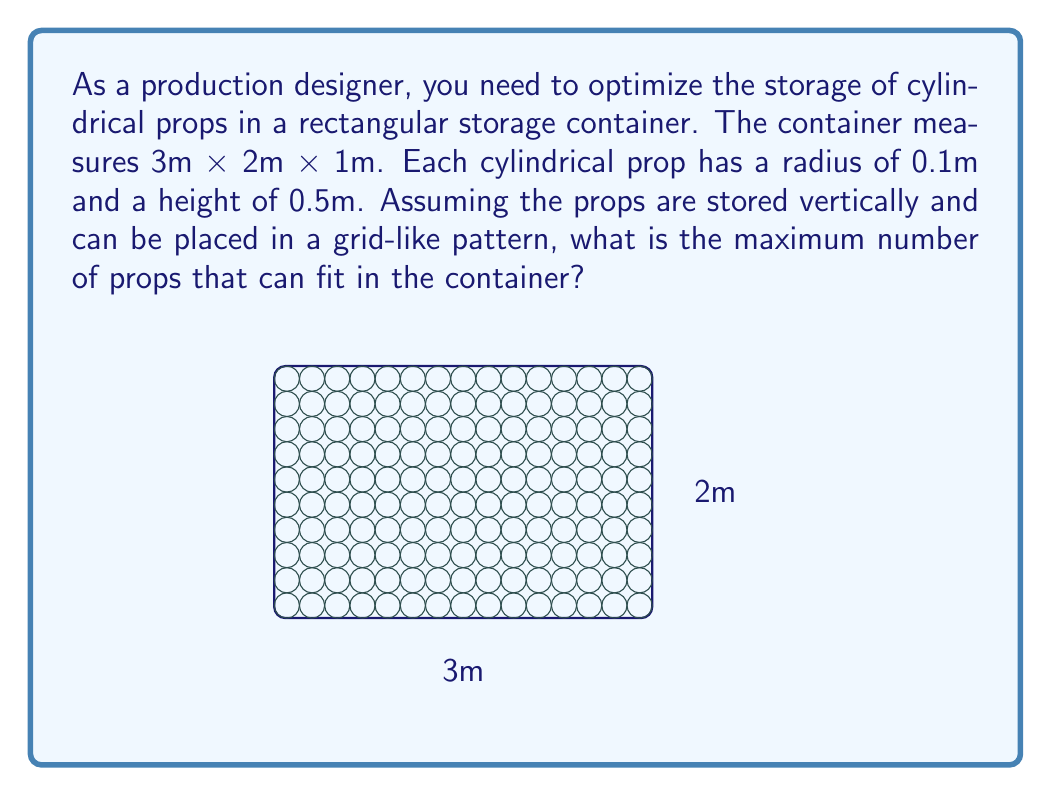Teach me how to tackle this problem. To solve this optimization problem, we need to follow these steps:

1) First, let's consider the base area of the container:
   Length = 3m, Width = 2m
   Base area = 3m × 2m = 6m²

2) Now, let's calculate how many props can fit along each dimension:

   For length: 
   $$\text{Number along length} = \left\lfloor\frac{3\text{m}}{2 \cdot 0.1\text{m}}\right\rfloor = \left\lfloor15\right\rfloor = 15$$

   For width:
   $$\text{Number along width} = \left\lfloor\frac{2\text{m}}{2 \cdot 0.1\text{m}}\right\rfloor = \left\lfloor10\right\rfloor = 10$$

   We use the floor function because we can't have partial props.

3) The total number of props that can fit in one layer:
   $$15 \times 10 = 150\text{ props}$$

4) Now, let's consider the height:
   Container height = 1m
   Prop height = 0.5m

5) Number of layers that can be stacked:
   $$\text{Number of layers} = \left\lfloor\frac{1\text{m}}{0.5\text{m}}\right\rfloor = 2$$

6) Therefore, the total number of props that can fit in the container:
   $$150\text{ props per layer} \times 2\text{ layers} = 300\text{ props}$$
Answer: 300 props 